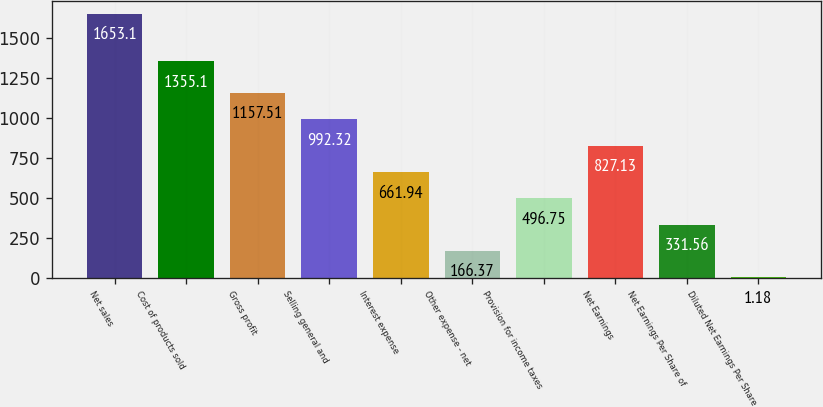Convert chart. <chart><loc_0><loc_0><loc_500><loc_500><bar_chart><fcel>Net sales<fcel>Cost of products sold<fcel>Gross profit<fcel>Selling general and<fcel>Interest expense<fcel>Other expense - net<fcel>Provision for income taxes<fcel>Net Earnings<fcel>Net Earnings Per Share of<fcel>Diluted Net Earnings Per Share<nl><fcel>1653.1<fcel>1355.1<fcel>1157.51<fcel>992.32<fcel>661.94<fcel>166.37<fcel>496.75<fcel>827.13<fcel>331.56<fcel>1.18<nl></chart> 